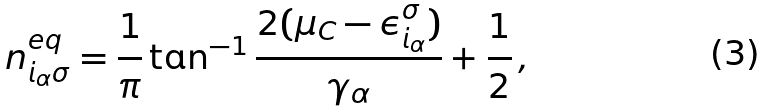Convert formula to latex. <formula><loc_0><loc_0><loc_500><loc_500>n ^ { e q } _ { i _ { \alpha } \sigma } = \frac { 1 } { \pi } \tan ^ { - 1 } \frac { 2 ( \mu _ { C } - \epsilon ^ { \sigma } _ { i _ { \alpha } } ) } { \gamma _ { \alpha } } + \frac { 1 } { 2 } \, ,</formula> 